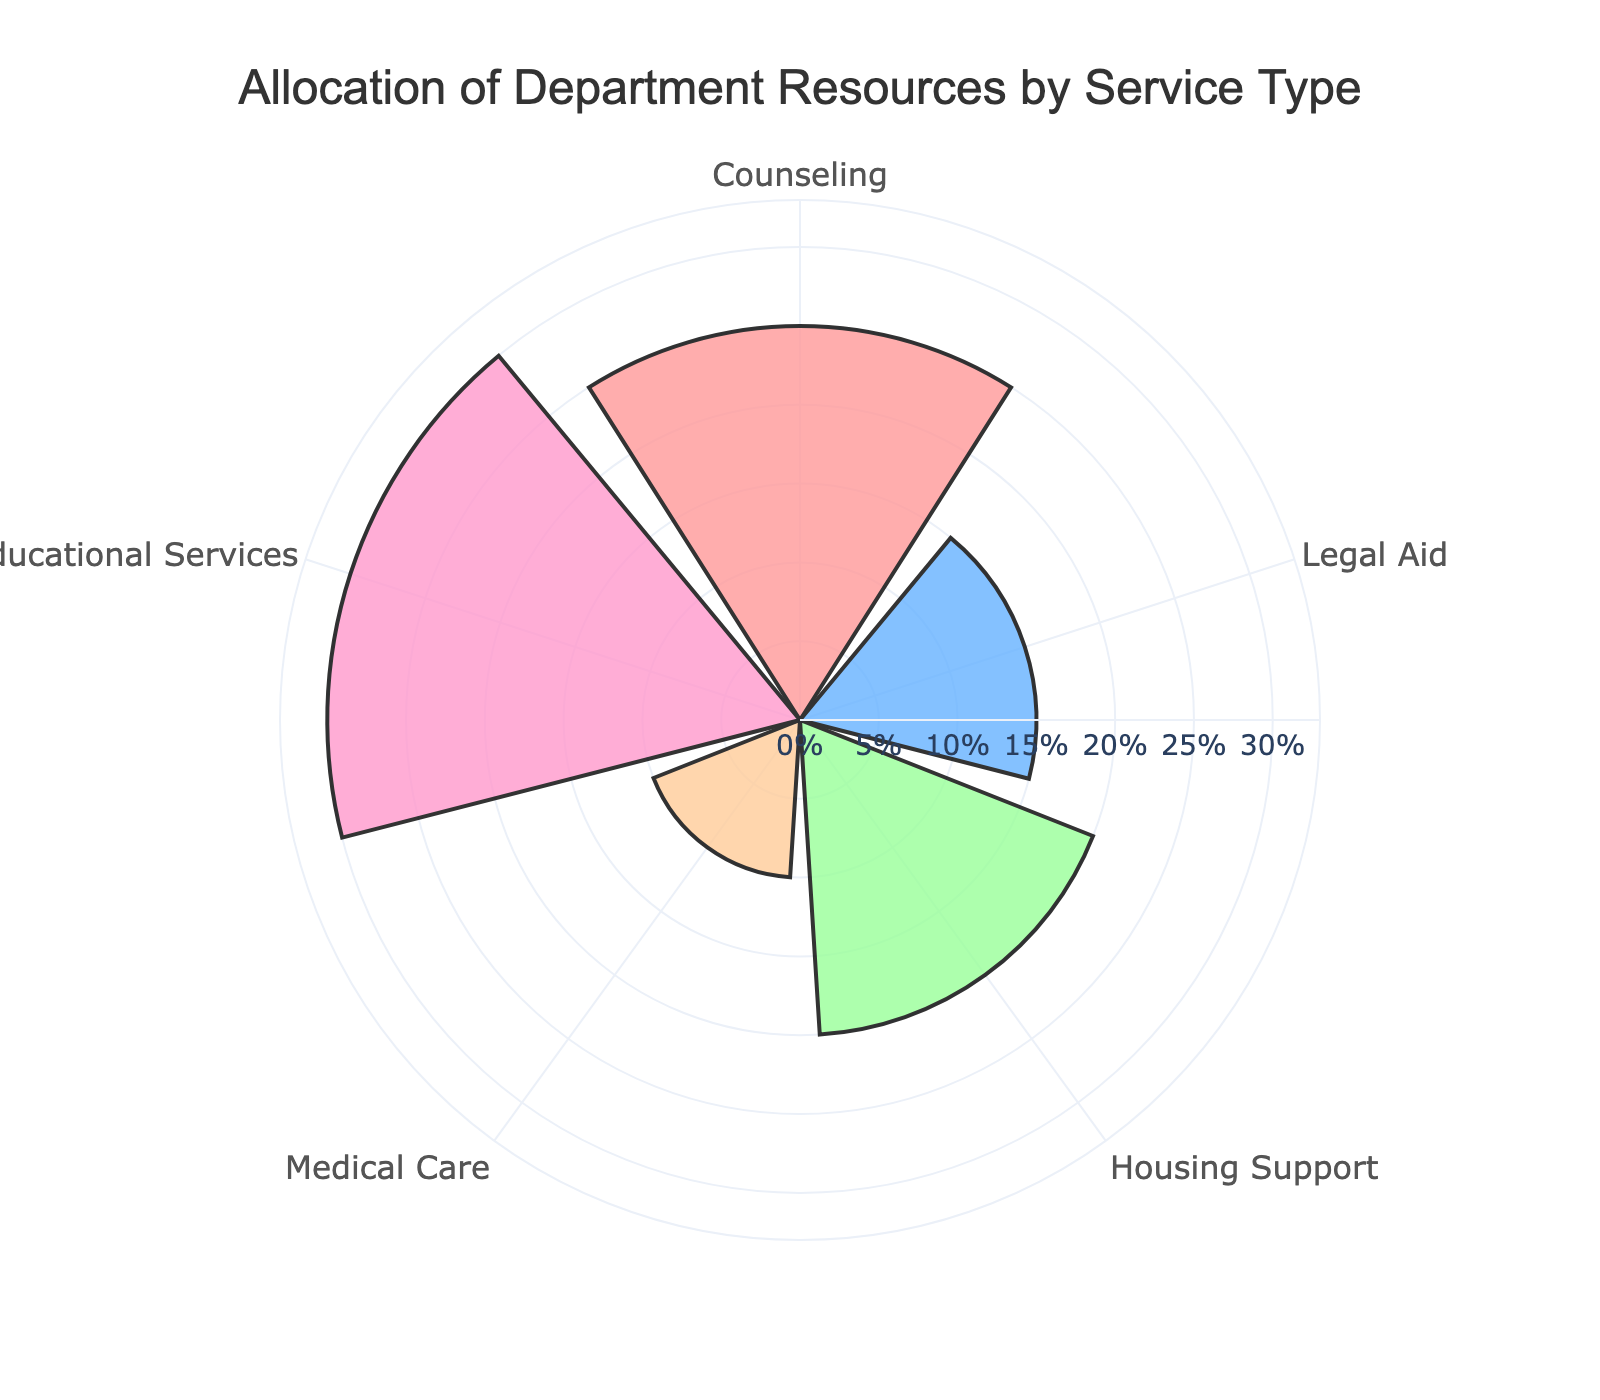What's the title of the chart? The chart title is given at the top center of the figure. It reads "Allocation of Department Resources by Service Type".
Answer: Allocation of Department Resources by Service Type How many service types are depicted in the chart? By counting all the distinct labels around the polar area, we can see there are five service types depicted.
Answer: 5 What percentage is allocated to Educational Services? Look at the radial line representing Educational Services; it reaches the 30% mark on the polar area chart.
Answer: 30% What is the sum of the allocation percentages for Counseling and Legal Aid? Counseling is allocated 25%, and Legal Aid is allocated 15%. Adding these together gives 25% + 15% = 40%.
Answer: 40% Which service type has the lowest resource allocation? By locating the smallest radial extent, Medical Care has the shortest bar, which corresponds to the lowest allocation of 10%.
Answer: Medical Care How much more is allocated to Housing Support compared to Medical Care? Housing Support is allocated 20%, and Medical Care is allocated 10%. The difference is 20% - 10% = 10%.
Answer: 10% What are the colors representing each service type in the chart? The colors for each service type (in order) are: Counseling (red), Legal Aid (blue), Housing Support (green), Medical Care (orange), Educational Services (pink).
Answer: Red, Blue, Green, Orange, Pink If the allocation for Medical Care were doubled, what would the new percentage be? The current allocation for Medical Care is 10%. Doubling it would result in 10% * 2 = 20%.
Answer: 20% Rank the service types based on their allocated percentage from highest to lowest. List the service types by decreasing radial line length: Educational Services (30%), Counseling (25%), Housing Support (20%), Legal Aid (15%), Medical Care (10%).
Answer: Educational Services, Counseling, Housing Support, Legal Aid, Medical Care Is the range for the radial axis visible on the chart? Yes, the radial axis shows a range from 0% to a little above the highest value which is 30%.
Answer: Yes 